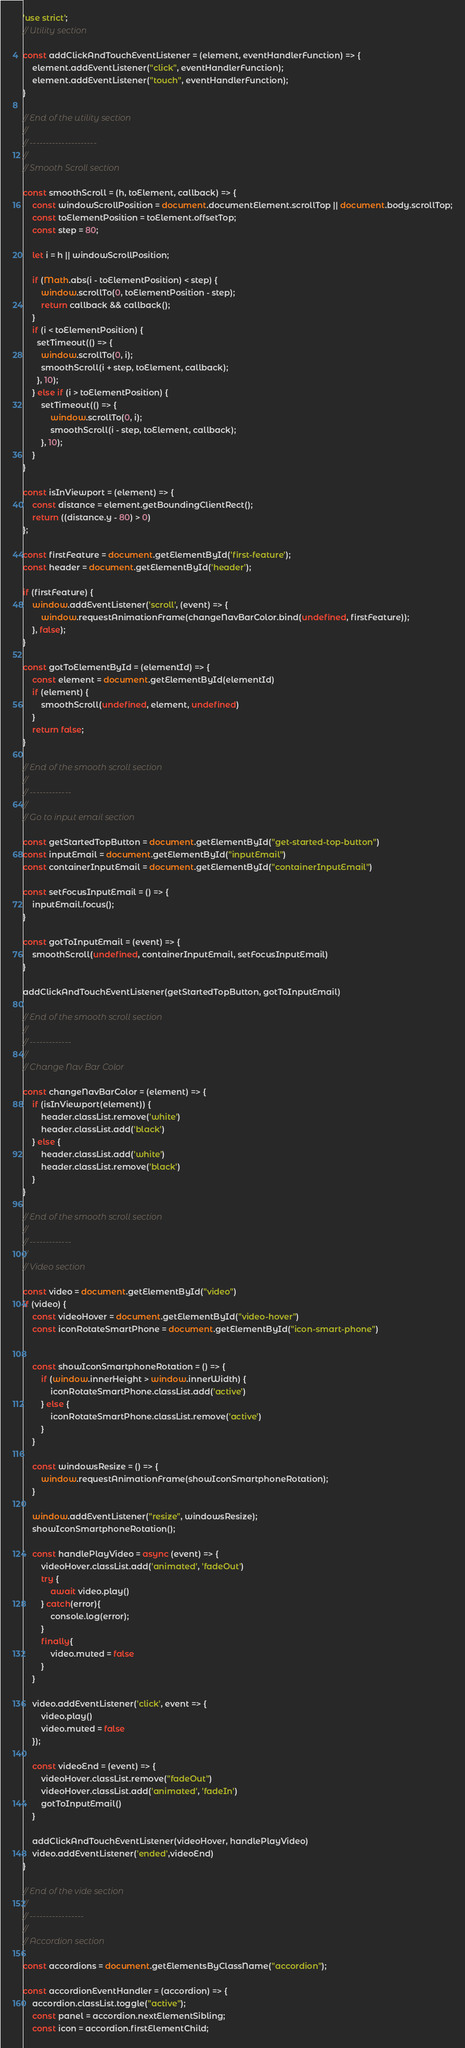Convert code to text. <code><loc_0><loc_0><loc_500><loc_500><_JavaScript_>'use strict';
// Utility section

const addClickAndTouchEventListener = (element, eventHandlerFunction) => {
    element.addEventListener("click", eventHandlerFunction);
    element.addEventListener("touch", eventHandlerFunction);
}

// End of the utility section
//
// ---------------------
//
// Smooth Scroll section

const smoothScroll = (h, toElement, callback) => {
    const windowScrollPosition = document.documentElement.scrollTop || document.body.scrollTop;
    const toElementPosition = toElement.offsetTop;
    const step = 80;

    let i = h || windowScrollPosition;
    
    if (Math.abs(i - toElementPosition) < step) {
        window.scrollTo(0, toElementPosition - step);
        return callback && callback();
    }
    if (i < toElementPosition) {
      setTimeout(() => {
        window.scrollTo(0, i);
        smoothScroll(i + step, toElement, callback);
      }, 10);
    } else if (i > toElementPosition) {
        setTimeout(() => {
            window.scrollTo(0, i);
            smoothScroll(i - step, toElement, callback);
        }, 10);
    }
}

const isInViewport = (element) => {
    const distance = element.getBoundingClientRect();
    return ((distance.y - 80) > 0)
};

const firstFeature = document.getElementById('first-feature');
const header = document.getElementById('header');

if (firstFeature) {
    window.addEventListener('scroll', (event) => {
        window.requestAnimationFrame(changeNavBarColor.bind(undefined, firstFeature));
    }, false);
}

const gotToElementById = (elementId) => {
    const element = document.getElementById(elementId)
    if (element) {
        smoothScroll(undefined, element, undefined)
    }
    return false;
}

// End of the smooth scroll section
//
// -------------
//
// Go to input email section

const getStartedTopButton = document.getElementById("get-started-top-button")
const inputEmail = document.getElementById("inputEmail")
const containerInputEmail = document.getElementById("containerInputEmail")

const setFocusInputEmail = () => {
    inputEmail.focus();
}

const gotToInputEmail = (event) => {
    smoothScroll(undefined, containerInputEmail, setFocusInputEmail)
}

addClickAndTouchEventListener(getStartedTopButton, gotToInputEmail)

// End of the smooth scroll section
//
// -------------
//
// Change Nav Bar Color

const changeNavBarColor = (element) => {
    if (isInViewport(element)) {
        header.classList.remove('white')
        header.classList.add('black')
    } else {
        header.classList.add('white')
        header.classList.remove('black')
    }
}

// End of the smooth scroll section
//
// -------------
//
// Video section

const video = document.getElementById("video")
if (video) {
    const videoHover = document.getElementById("video-hover")
    const iconRotateSmartPhone = document.getElementById("icon-smart-phone")

    
    const showIconSmartphoneRotation = () => {
        if (window.innerHeight > window.innerWidth) {
            iconRotateSmartPhone.classList.add('active')
        } else {
            iconRotateSmartPhone.classList.remove('active')
        }
    }

    const windowsResize = () => {
        window.requestAnimationFrame(showIconSmartphoneRotation);
    }

    window.addEventListener("resize", windowsResize);
    showIconSmartphoneRotation();
    
    const handlePlayVideo = async (event) => {
        videoHover.classList.add('animated', 'fadeOut')
        try {
            await video.play()
        } catch(error){
            console.log(error);
        }
        finally{
            video.muted = false
        }
    }

    video.addEventListener('click', event => {
        video.play()
        video.muted = false
    });

    const videoEnd = (event) => {
        videoHover.classList.remove("fadeOut")
        videoHover.classList.add('animated', 'fadeIn')
        gotToInputEmail()
    }

    addClickAndTouchEventListener(videoHover, handlePlayVideo)
    video.addEventListener('ended',videoEnd)
}

// End of the vide section
//
// -----------------
//
// Accordion section

const accordions = document.getElementsByClassName("accordion");

const accordionEventHandler = (accordion) => {
    accordion.classList.toggle("active");
    const panel = accordion.nextElementSibling;
    const icon = accordion.firstElementChild;</code> 